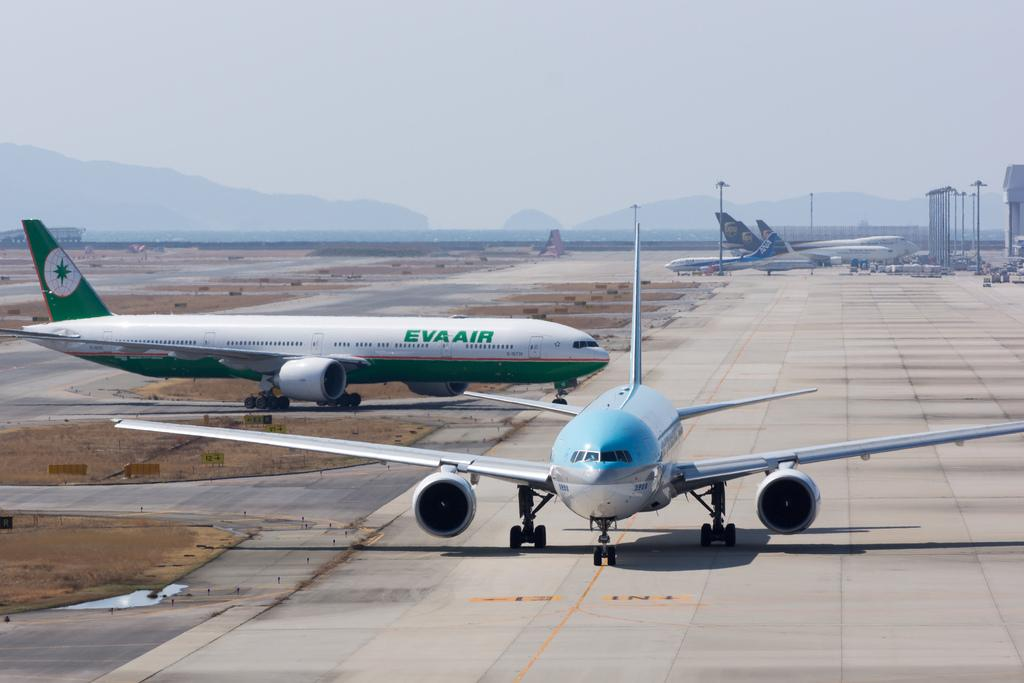Provide a one-sentence caption for the provided image. Two air planes on a run way, one of which is green with Eva Air written on the side. 